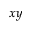<formula> <loc_0><loc_0><loc_500><loc_500>x y</formula> 